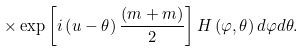<formula> <loc_0><loc_0><loc_500><loc_500>\times \exp \left [ i \left ( u - \theta \right ) \frac { \left ( m + m \right ) } { 2 } \right ] H \left ( \varphi , \theta \right ) d \varphi d \theta .</formula> 